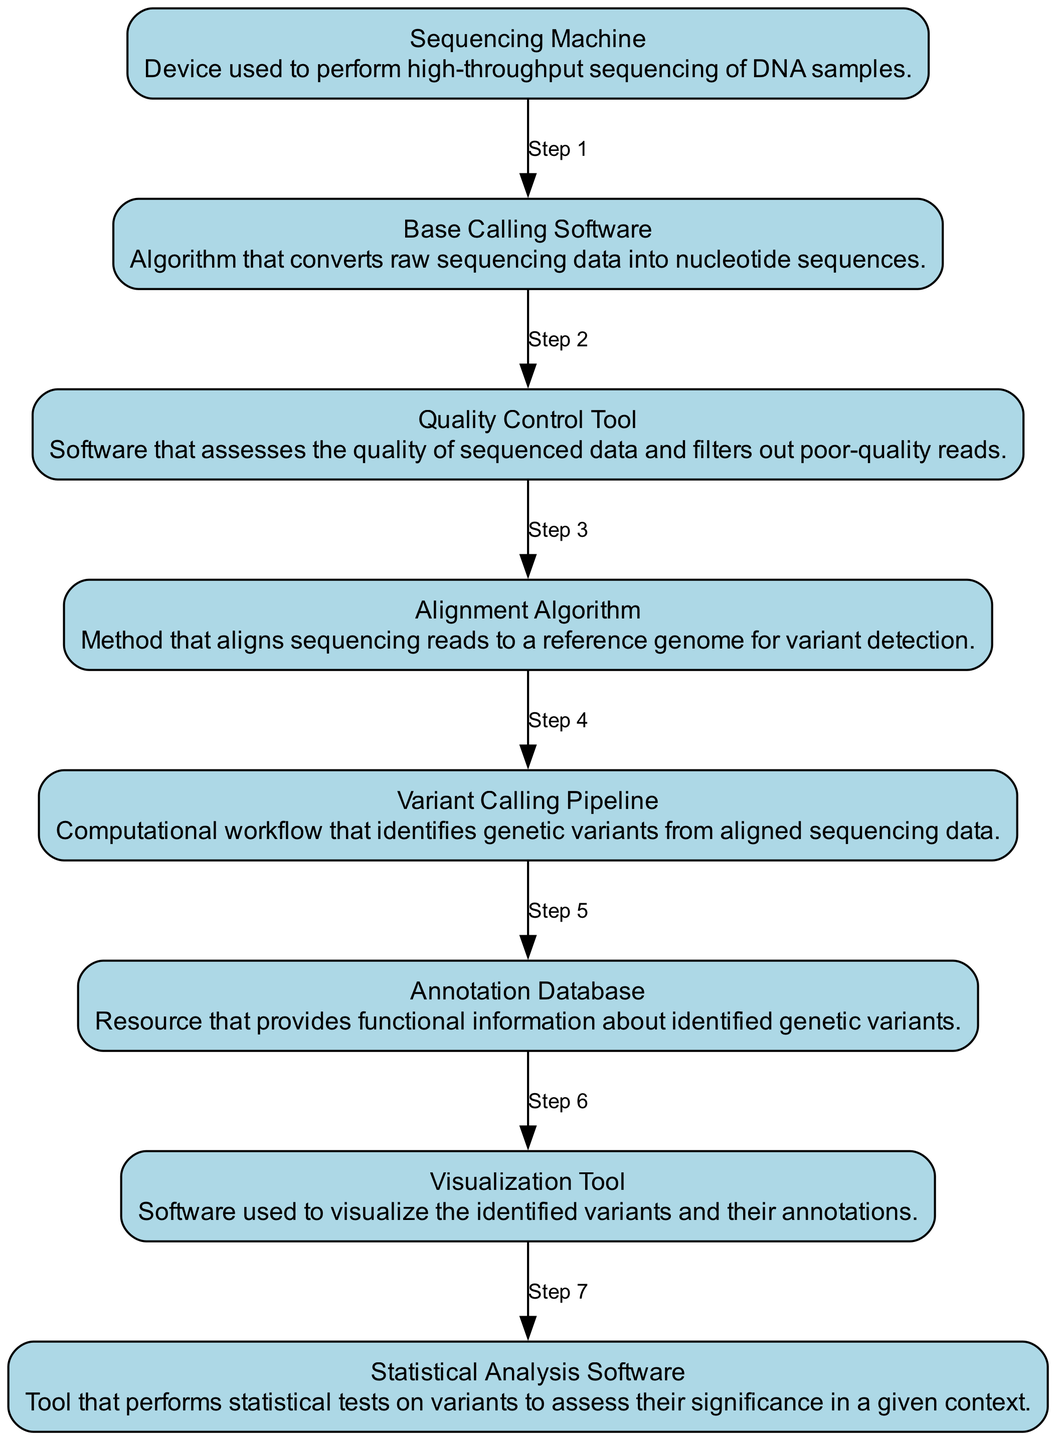What is the first step in the data pipeline? The first step is performed by the Sequencing Machine, which is responsible for high-throughput sequencing of DNA samples.
Answer: Sequencing Machine How many nodes are there in the data pipeline? The diagram contains 8 nodes, each representing a step in the data processing workflow.
Answer: 8 Which software is used after the Base Calling Software? After the Base Calling Software, the Quality Control Tool is used to assess and filter the sequenced data quality.
Answer: Quality Control Tool What step follows the Alignment Algorithm? Following the Alignment Algorithm, the next step is the Variant Calling Pipeline which identifies genetic variants.
Answer: Variant Calling Pipeline What is the role of the Annotation Database in the pipeline? The Annotation Database provides functional information about the identified genetic variants after they are called.
Answer: Provides functional information How many flows are there from the Variant Calling Pipeline? There are two flows from the Variant Calling Pipeline: one leads to the Annotation Database and the other to the Statistical Analysis Software.
Answer: 2 What is the relationship between the Quality Control Tool and the Alignment Algorithm? The Quality Control Tool directly precedes the Alignment Algorithm, ensuring that only high-quality reads are aligned for variant detection.
Answer: Precedes What do the Visualization Tool and Statistical Analysis Software have in common? Both of these tools handle the output from the Variant Calling Pipeline, with the Visualization Tool focusing on visual representation and the Statistical Analysis Software performing statistical tests.
Answer: Handle output from Variant Calling Pipeline What is the final stage of the data pipeline? The final stage of the data pipeline is the Statistical Analysis Software, where statistical assessment of variants takes place.
Answer: Statistical Analysis Software 